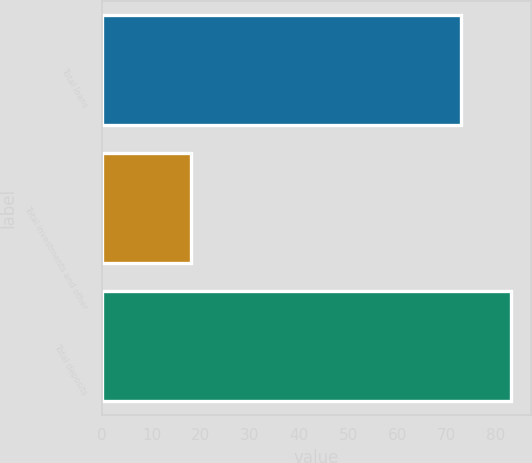Convert chart. <chart><loc_0><loc_0><loc_500><loc_500><bar_chart><fcel>Total loans<fcel>Total investments and other<fcel>Total deposits<nl><fcel>73<fcel>18<fcel>83<nl></chart> 